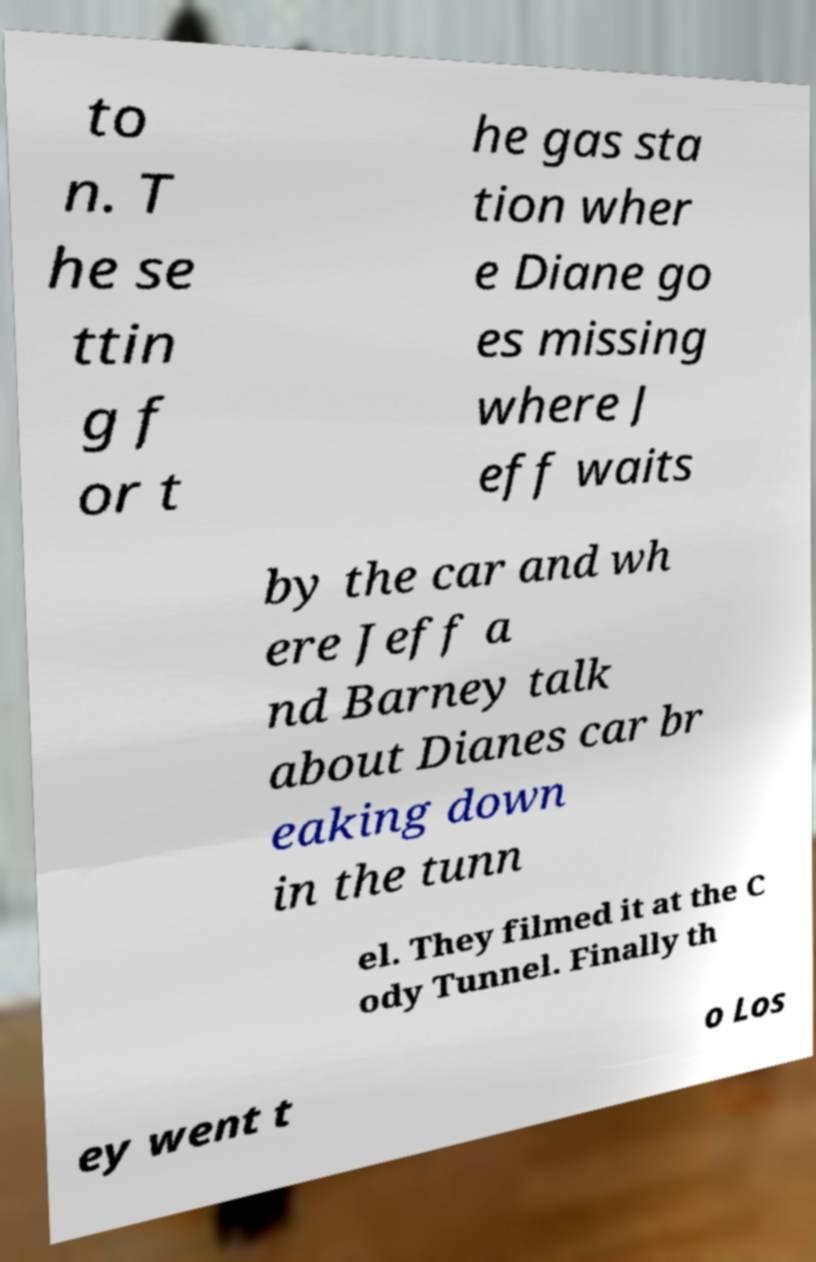What messages or text are displayed in this image? I need them in a readable, typed format. to n. T he se ttin g f or t he gas sta tion wher e Diane go es missing where J eff waits by the car and wh ere Jeff a nd Barney talk about Dianes car br eaking down in the tunn el. They filmed it at the C ody Tunnel. Finally th ey went t o Los 